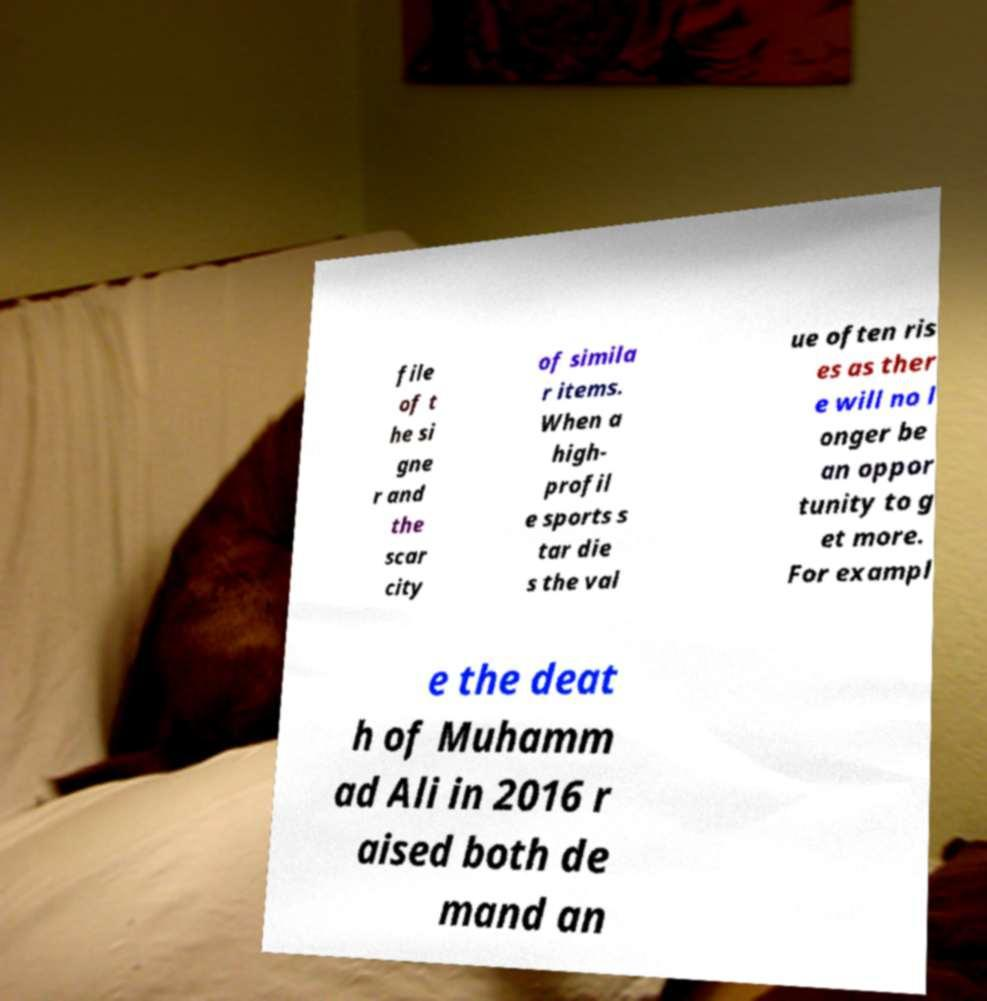For documentation purposes, I need the text within this image transcribed. Could you provide that? file of t he si gne r and the scar city of simila r items. When a high- profil e sports s tar die s the val ue often ris es as ther e will no l onger be an oppor tunity to g et more. For exampl e the deat h of Muhamm ad Ali in 2016 r aised both de mand an 